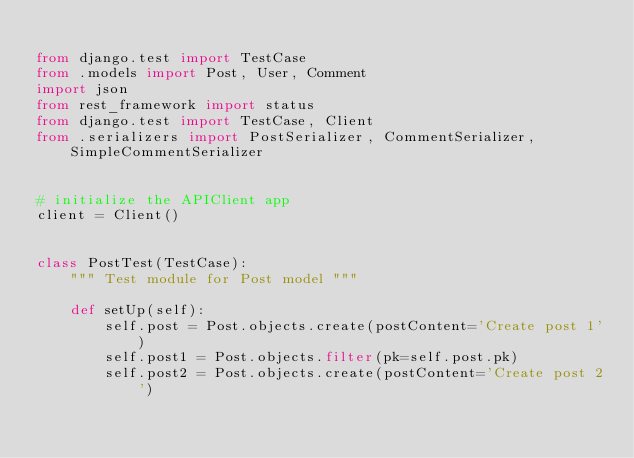<code> <loc_0><loc_0><loc_500><loc_500><_Python_>
from django.test import TestCase
from .models import Post, User, Comment
import json
from rest_framework import status
from django.test import TestCase, Client
from .serializers import PostSerializer, CommentSerializer, SimpleCommentSerializer


# initialize the APIClient app
client = Client()


class PostTest(TestCase):
    """ Test module for Post model """

    def setUp(self):
        self.post = Post.objects.create(postContent='Create post 1')
        self.post1 = Post.objects.filter(pk=self.post.pk)
        self.post2 = Post.objects.create(postContent='Create post 2')</code> 